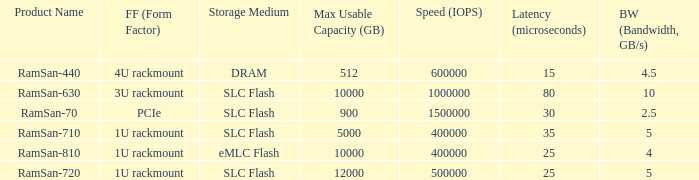What is the ramsan-810 transfer delay? 1.0. 